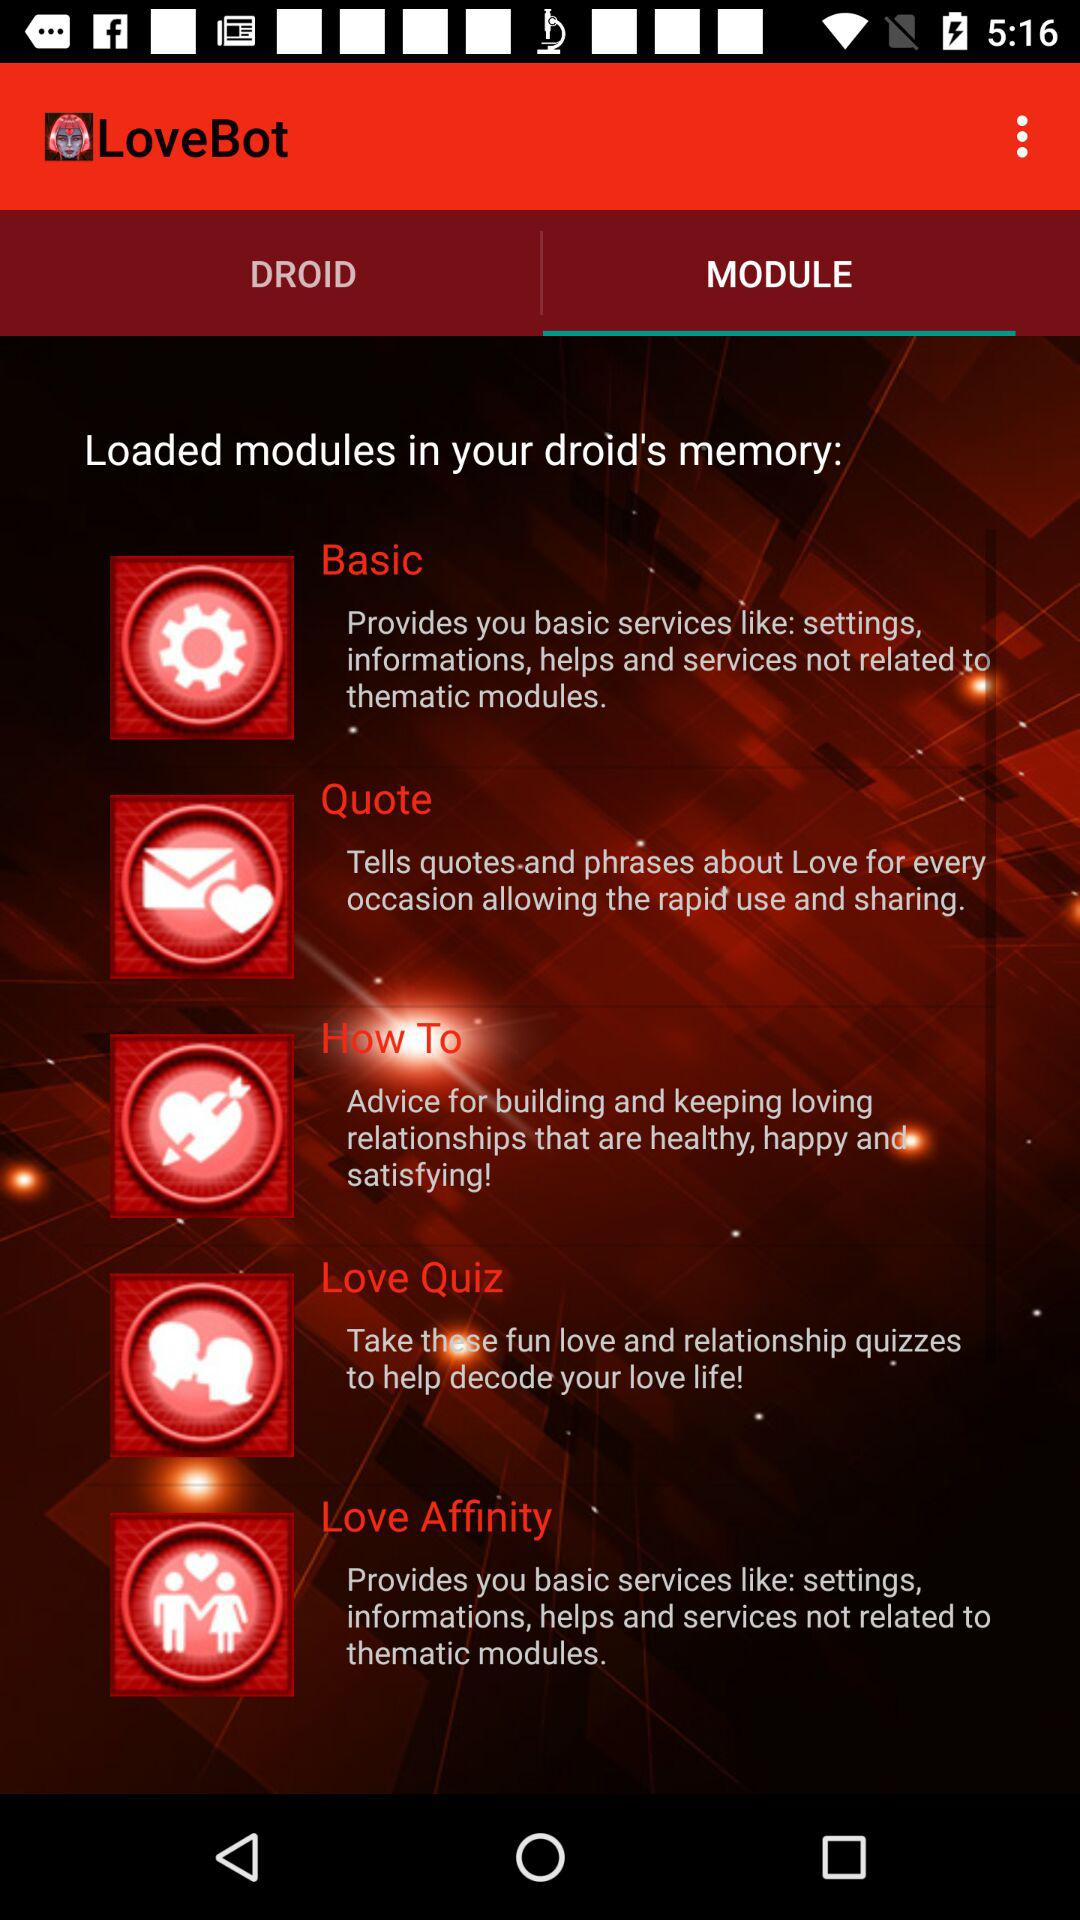What is the application name? The application name is "LoveBot". 